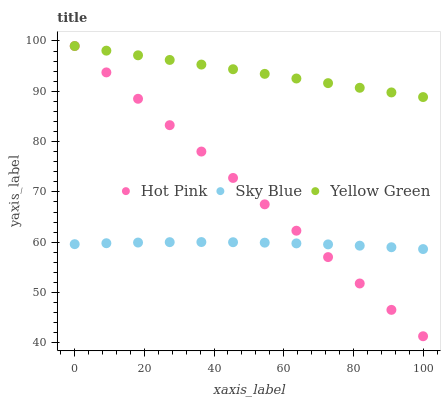Does Sky Blue have the minimum area under the curve?
Answer yes or no. Yes. Does Yellow Green have the maximum area under the curve?
Answer yes or no. Yes. Does Hot Pink have the minimum area under the curve?
Answer yes or no. No. Does Hot Pink have the maximum area under the curve?
Answer yes or no. No. Is Hot Pink the smoothest?
Answer yes or no. Yes. Is Sky Blue the roughest?
Answer yes or no. Yes. Is Yellow Green the smoothest?
Answer yes or no. No. Is Yellow Green the roughest?
Answer yes or no. No. Does Hot Pink have the lowest value?
Answer yes or no. Yes. Does Yellow Green have the lowest value?
Answer yes or no. No. Does Yellow Green have the highest value?
Answer yes or no. Yes. Is Sky Blue less than Yellow Green?
Answer yes or no. Yes. Is Yellow Green greater than Sky Blue?
Answer yes or no. Yes. Does Hot Pink intersect Sky Blue?
Answer yes or no. Yes. Is Hot Pink less than Sky Blue?
Answer yes or no. No. Is Hot Pink greater than Sky Blue?
Answer yes or no. No. Does Sky Blue intersect Yellow Green?
Answer yes or no. No. 